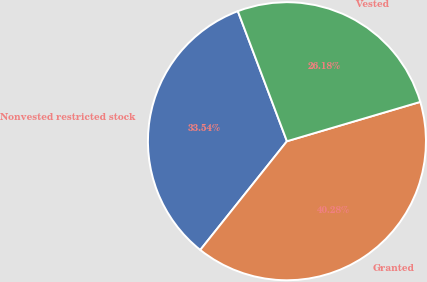<chart> <loc_0><loc_0><loc_500><loc_500><pie_chart><fcel>Nonvested restricted stock<fcel>Granted<fcel>Vested<nl><fcel>33.54%<fcel>40.28%<fcel>26.18%<nl></chart> 